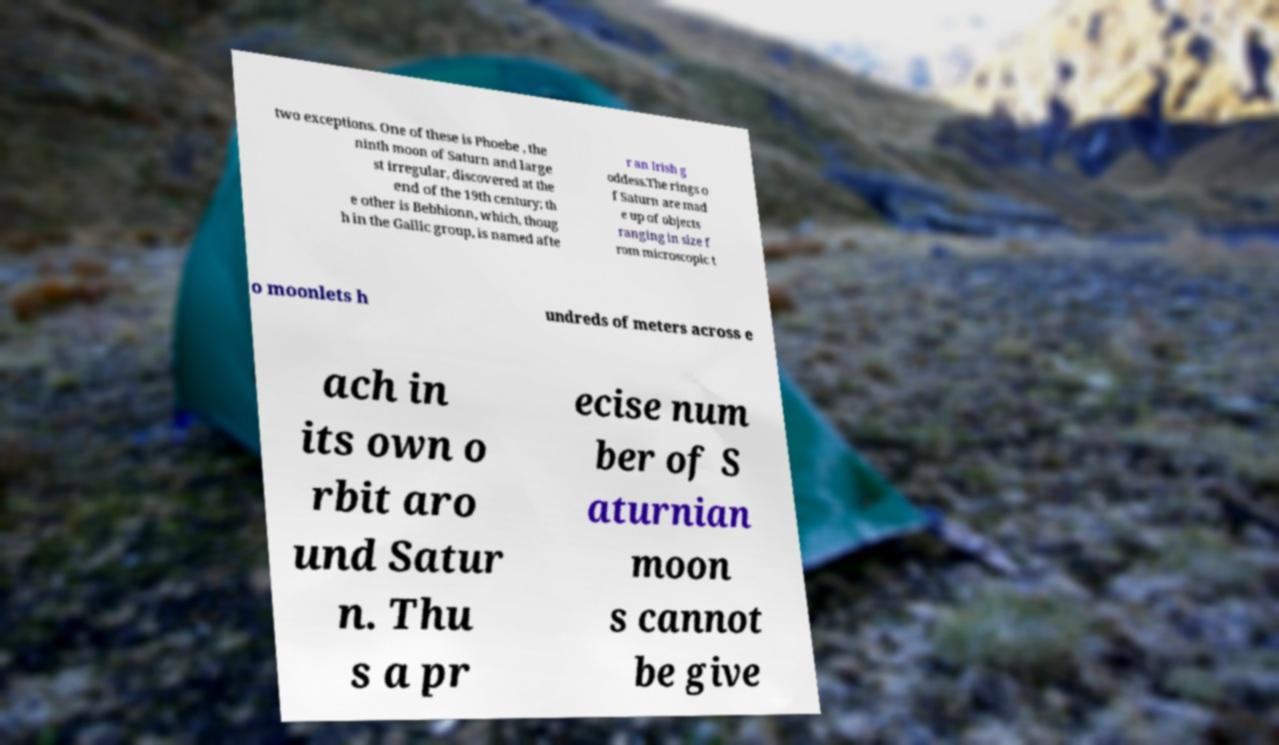I need the written content from this picture converted into text. Can you do that? two exceptions. One of these is Phoebe , the ninth moon of Saturn and large st irregular, discovered at the end of the 19th century; th e other is Bebhionn, which, thoug h in the Gallic group, is named afte r an Irish g oddess.The rings o f Saturn are mad e up of objects ranging in size f rom microscopic t o moonlets h undreds of meters across e ach in its own o rbit aro und Satur n. Thu s a pr ecise num ber of S aturnian moon s cannot be give 